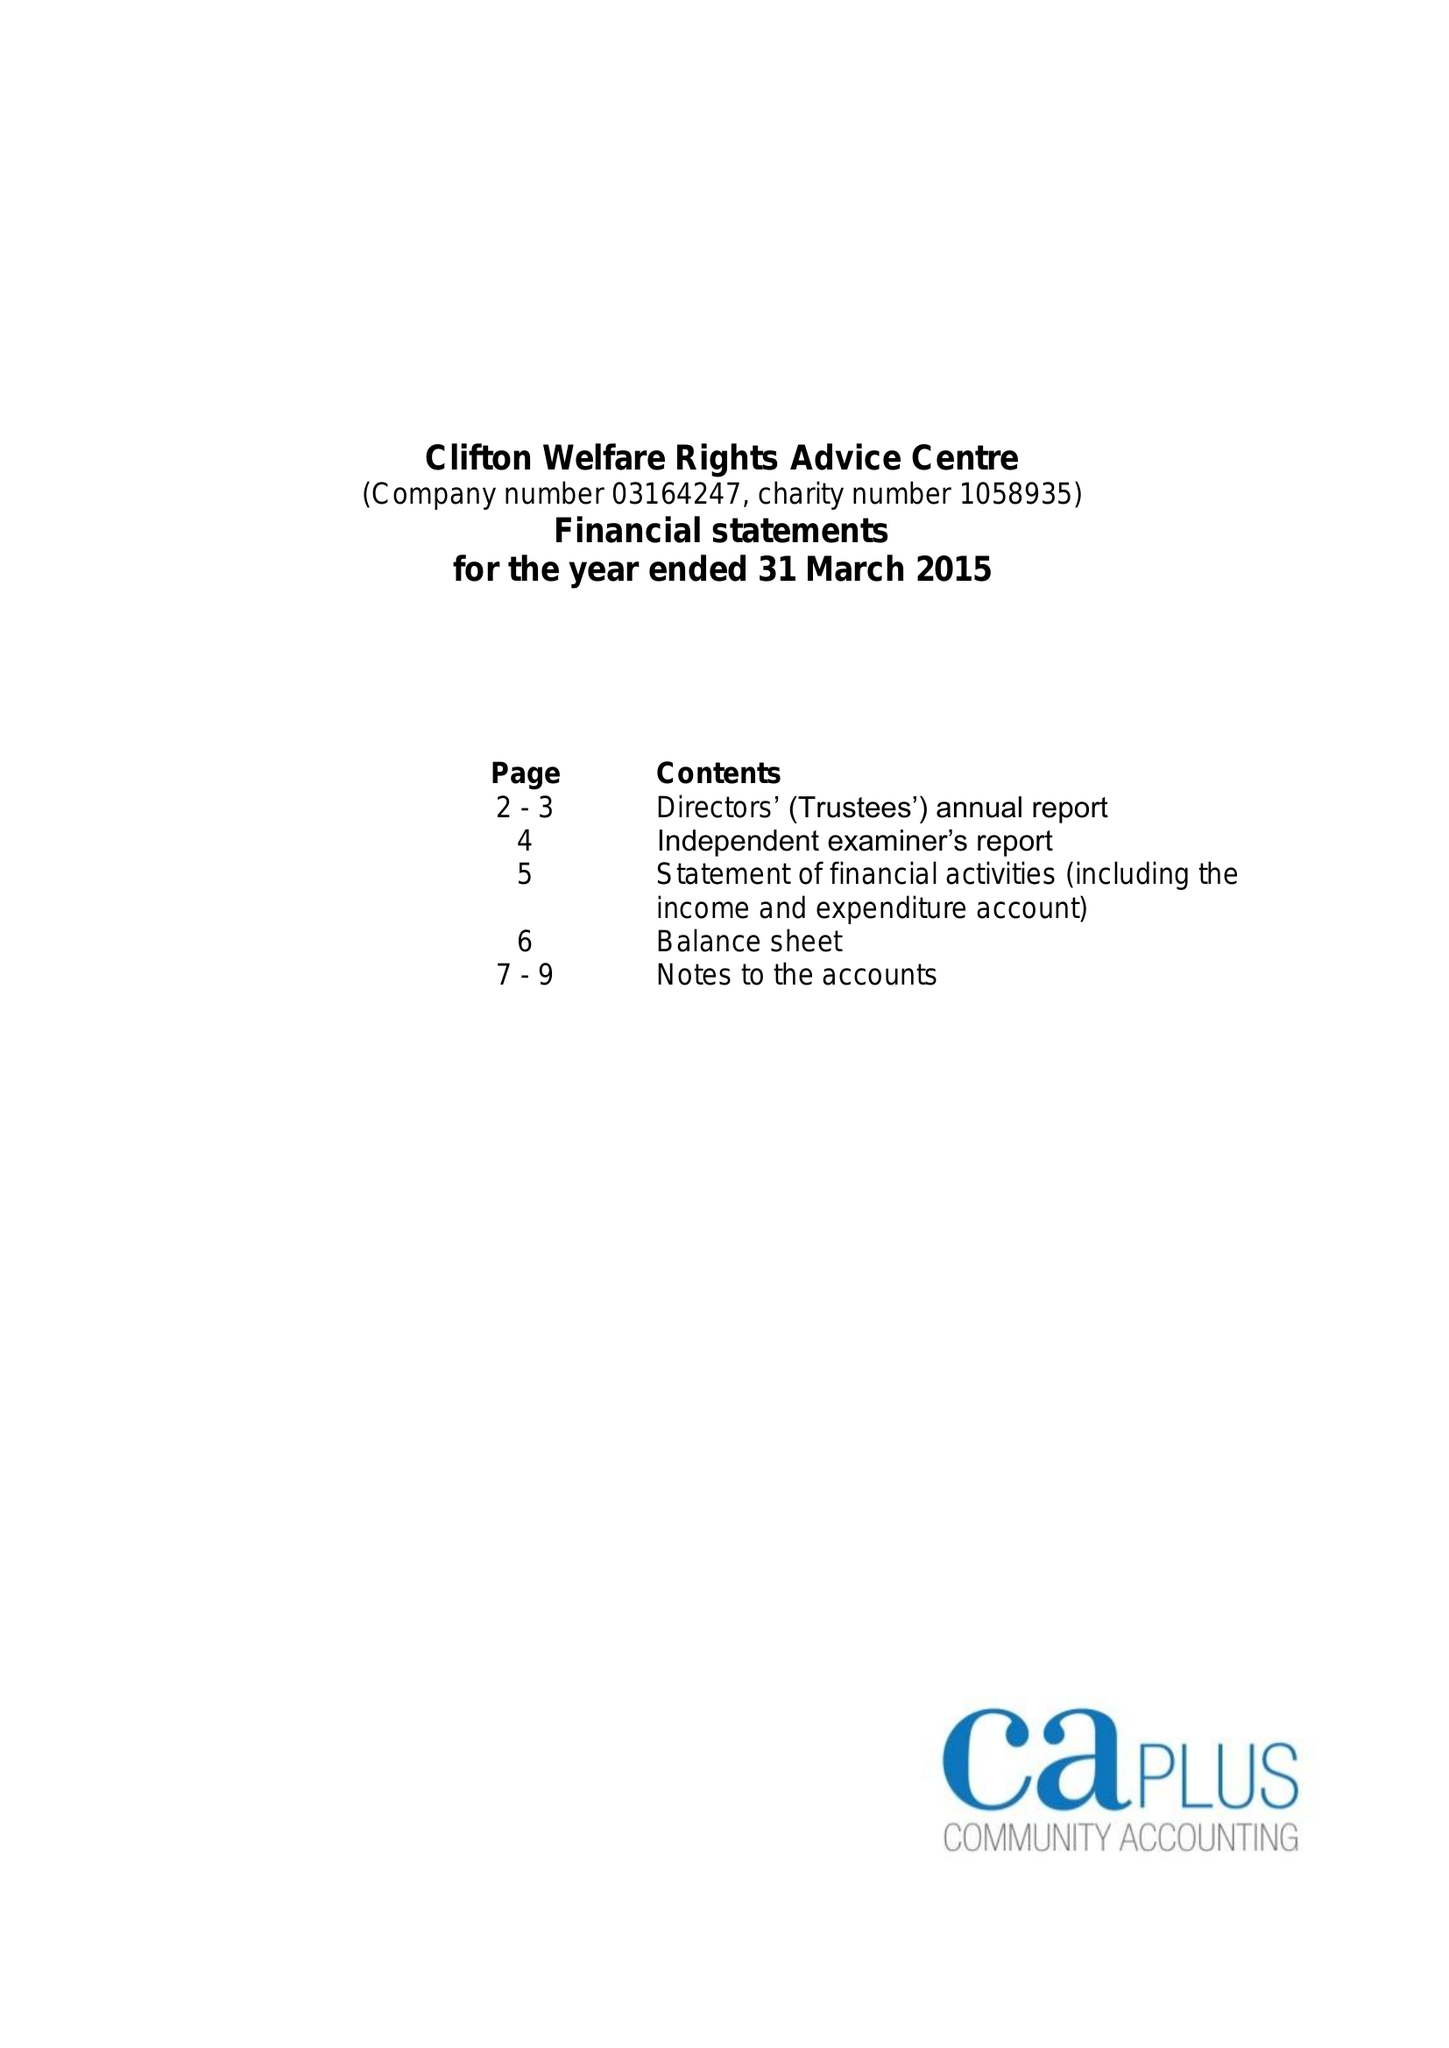What is the value for the address__postcode?
Answer the question using a single word or phrase. NG11 8EW 